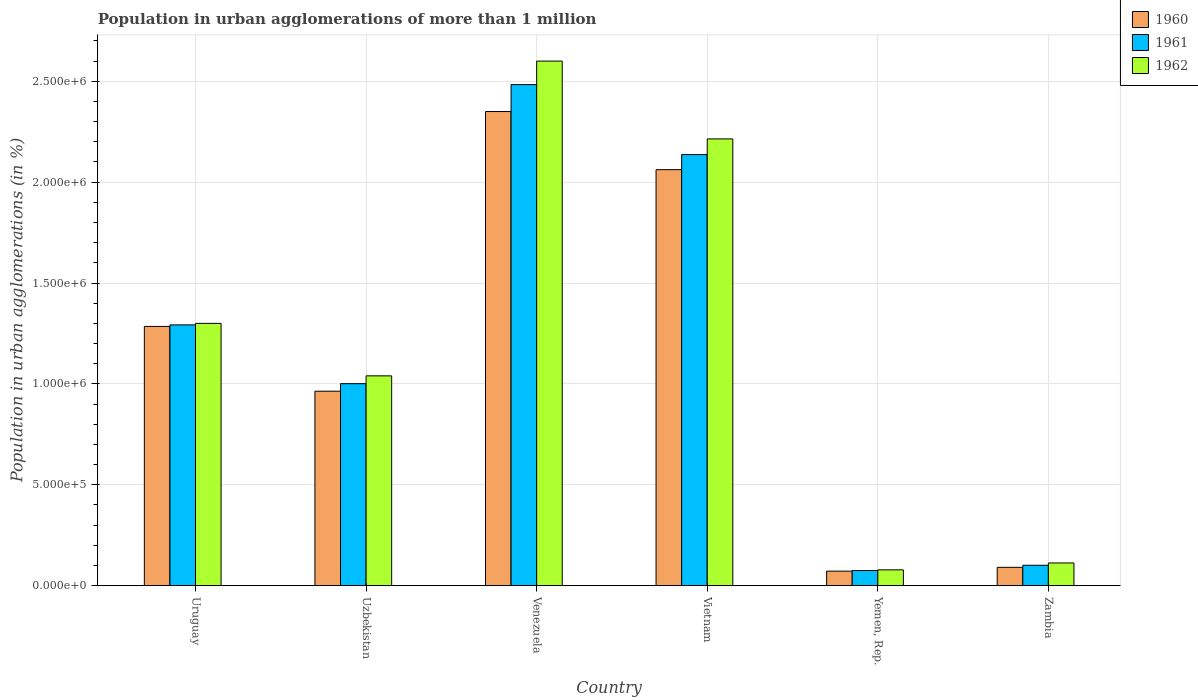How many different coloured bars are there?
Offer a very short reply. 3. How many groups of bars are there?
Your answer should be compact. 6. How many bars are there on the 6th tick from the right?
Ensure brevity in your answer.  3. What is the label of the 5th group of bars from the left?
Offer a very short reply. Yemen, Rep. In how many cases, is the number of bars for a given country not equal to the number of legend labels?
Give a very brief answer. 0. What is the population in urban agglomerations in 1961 in Vietnam?
Keep it short and to the point. 2.14e+06. Across all countries, what is the maximum population in urban agglomerations in 1960?
Offer a very short reply. 2.35e+06. Across all countries, what is the minimum population in urban agglomerations in 1962?
Offer a very short reply. 7.84e+04. In which country was the population in urban agglomerations in 1961 maximum?
Make the answer very short. Venezuela. In which country was the population in urban agglomerations in 1961 minimum?
Offer a very short reply. Yemen, Rep. What is the total population in urban agglomerations in 1961 in the graph?
Offer a very short reply. 7.09e+06. What is the difference between the population in urban agglomerations in 1960 in Uruguay and that in Venezuela?
Offer a terse response. -1.07e+06. What is the difference between the population in urban agglomerations in 1962 in Yemen, Rep. and the population in urban agglomerations in 1961 in Vietnam?
Offer a very short reply. -2.06e+06. What is the average population in urban agglomerations in 1962 per country?
Your answer should be compact. 1.22e+06. What is the difference between the population in urban agglomerations of/in 1961 and population in urban agglomerations of/in 1962 in Yemen, Rep.?
Give a very brief answer. -3293. What is the ratio of the population in urban agglomerations in 1961 in Uzbekistan to that in Zambia?
Your response must be concise. 9.89. Is the population in urban agglomerations in 1962 in Uruguay less than that in Vietnam?
Ensure brevity in your answer.  Yes. What is the difference between the highest and the second highest population in urban agglomerations in 1960?
Give a very brief answer. -2.88e+05. What is the difference between the highest and the lowest population in urban agglomerations in 1962?
Keep it short and to the point. 2.52e+06. How many bars are there?
Offer a terse response. 18. How many countries are there in the graph?
Keep it short and to the point. 6. Are the values on the major ticks of Y-axis written in scientific E-notation?
Ensure brevity in your answer.  Yes. Does the graph contain grids?
Make the answer very short. Yes. Where does the legend appear in the graph?
Give a very brief answer. Top right. What is the title of the graph?
Your answer should be very brief. Population in urban agglomerations of more than 1 million. What is the label or title of the X-axis?
Offer a very short reply. Country. What is the label or title of the Y-axis?
Provide a short and direct response. Population in urban agglomerations (in %). What is the Population in urban agglomerations (in %) in 1960 in Uruguay?
Offer a terse response. 1.28e+06. What is the Population in urban agglomerations (in %) in 1961 in Uruguay?
Your answer should be very brief. 1.29e+06. What is the Population in urban agglomerations (in %) in 1962 in Uruguay?
Make the answer very short. 1.30e+06. What is the Population in urban agglomerations (in %) in 1960 in Uzbekistan?
Provide a succinct answer. 9.64e+05. What is the Population in urban agglomerations (in %) of 1961 in Uzbekistan?
Offer a very short reply. 1.00e+06. What is the Population in urban agglomerations (in %) of 1962 in Uzbekistan?
Your response must be concise. 1.04e+06. What is the Population in urban agglomerations (in %) in 1960 in Venezuela?
Offer a terse response. 2.35e+06. What is the Population in urban agglomerations (in %) of 1961 in Venezuela?
Offer a terse response. 2.48e+06. What is the Population in urban agglomerations (in %) in 1962 in Venezuela?
Keep it short and to the point. 2.60e+06. What is the Population in urban agglomerations (in %) of 1960 in Vietnam?
Offer a very short reply. 2.06e+06. What is the Population in urban agglomerations (in %) in 1961 in Vietnam?
Provide a short and direct response. 2.14e+06. What is the Population in urban agglomerations (in %) of 1962 in Vietnam?
Give a very brief answer. 2.21e+06. What is the Population in urban agglomerations (in %) of 1960 in Yemen, Rep.?
Provide a succinct answer. 7.20e+04. What is the Population in urban agglomerations (in %) of 1961 in Yemen, Rep.?
Provide a succinct answer. 7.52e+04. What is the Population in urban agglomerations (in %) in 1962 in Yemen, Rep.?
Your answer should be very brief. 7.84e+04. What is the Population in urban agglomerations (in %) in 1960 in Zambia?
Keep it short and to the point. 9.09e+04. What is the Population in urban agglomerations (in %) in 1961 in Zambia?
Make the answer very short. 1.01e+05. What is the Population in urban agglomerations (in %) of 1962 in Zambia?
Your answer should be compact. 1.13e+05. Across all countries, what is the maximum Population in urban agglomerations (in %) of 1960?
Your response must be concise. 2.35e+06. Across all countries, what is the maximum Population in urban agglomerations (in %) in 1961?
Give a very brief answer. 2.48e+06. Across all countries, what is the maximum Population in urban agglomerations (in %) of 1962?
Your response must be concise. 2.60e+06. Across all countries, what is the minimum Population in urban agglomerations (in %) in 1960?
Ensure brevity in your answer.  7.20e+04. Across all countries, what is the minimum Population in urban agglomerations (in %) in 1961?
Your response must be concise. 7.52e+04. Across all countries, what is the minimum Population in urban agglomerations (in %) in 1962?
Provide a succinct answer. 7.84e+04. What is the total Population in urban agglomerations (in %) in 1960 in the graph?
Ensure brevity in your answer.  6.82e+06. What is the total Population in urban agglomerations (in %) of 1961 in the graph?
Provide a short and direct response. 7.09e+06. What is the total Population in urban agglomerations (in %) of 1962 in the graph?
Your answer should be very brief. 7.35e+06. What is the difference between the Population in urban agglomerations (in %) of 1960 in Uruguay and that in Uzbekistan?
Provide a succinct answer. 3.21e+05. What is the difference between the Population in urban agglomerations (in %) of 1961 in Uruguay and that in Uzbekistan?
Provide a succinct answer. 2.91e+05. What is the difference between the Population in urban agglomerations (in %) in 1962 in Uruguay and that in Uzbekistan?
Your answer should be compact. 2.60e+05. What is the difference between the Population in urban agglomerations (in %) of 1960 in Uruguay and that in Venezuela?
Your answer should be compact. -1.07e+06. What is the difference between the Population in urban agglomerations (in %) in 1961 in Uruguay and that in Venezuela?
Provide a short and direct response. -1.19e+06. What is the difference between the Population in urban agglomerations (in %) of 1962 in Uruguay and that in Venezuela?
Offer a very short reply. -1.30e+06. What is the difference between the Population in urban agglomerations (in %) in 1960 in Uruguay and that in Vietnam?
Your answer should be compact. -7.77e+05. What is the difference between the Population in urban agglomerations (in %) in 1961 in Uruguay and that in Vietnam?
Make the answer very short. -8.44e+05. What is the difference between the Population in urban agglomerations (in %) of 1962 in Uruguay and that in Vietnam?
Ensure brevity in your answer.  -9.14e+05. What is the difference between the Population in urban agglomerations (in %) in 1960 in Uruguay and that in Yemen, Rep.?
Offer a terse response. 1.21e+06. What is the difference between the Population in urban agglomerations (in %) of 1961 in Uruguay and that in Yemen, Rep.?
Provide a short and direct response. 1.22e+06. What is the difference between the Population in urban agglomerations (in %) in 1962 in Uruguay and that in Yemen, Rep.?
Give a very brief answer. 1.22e+06. What is the difference between the Population in urban agglomerations (in %) of 1960 in Uruguay and that in Zambia?
Keep it short and to the point. 1.19e+06. What is the difference between the Population in urban agglomerations (in %) of 1961 in Uruguay and that in Zambia?
Your response must be concise. 1.19e+06. What is the difference between the Population in urban agglomerations (in %) in 1962 in Uruguay and that in Zambia?
Make the answer very short. 1.19e+06. What is the difference between the Population in urban agglomerations (in %) of 1960 in Uzbekistan and that in Venezuela?
Provide a short and direct response. -1.39e+06. What is the difference between the Population in urban agglomerations (in %) in 1961 in Uzbekistan and that in Venezuela?
Provide a succinct answer. -1.48e+06. What is the difference between the Population in urban agglomerations (in %) of 1962 in Uzbekistan and that in Venezuela?
Provide a succinct answer. -1.56e+06. What is the difference between the Population in urban agglomerations (in %) in 1960 in Uzbekistan and that in Vietnam?
Your answer should be very brief. -1.10e+06. What is the difference between the Population in urban agglomerations (in %) of 1961 in Uzbekistan and that in Vietnam?
Provide a succinct answer. -1.14e+06. What is the difference between the Population in urban agglomerations (in %) in 1962 in Uzbekistan and that in Vietnam?
Make the answer very short. -1.17e+06. What is the difference between the Population in urban agglomerations (in %) of 1960 in Uzbekistan and that in Yemen, Rep.?
Offer a very short reply. 8.92e+05. What is the difference between the Population in urban agglomerations (in %) of 1961 in Uzbekistan and that in Yemen, Rep.?
Your response must be concise. 9.26e+05. What is the difference between the Population in urban agglomerations (in %) of 1962 in Uzbekistan and that in Yemen, Rep.?
Your answer should be very brief. 9.61e+05. What is the difference between the Population in urban agglomerations (in %) of 1960 in Uzbekistan and that in Zambia?
Make the answer very short. 8.73e+05. What is the difference between the Population in urban agglomerations (in %) of 1961 in Uzbekistan and that in Zambia?
Give a very brief answer. 9.00e+05. What is the difference between the Population in urban agglomerations (in %) of 1962 in Uzbekistan and that in Zambia?
Ensure brevity in your answer.  9.27e+05. What is the difference between the Population in urban agglomerations (in %) in 1960 in Venezuela and that in Vietnam?
Your answer should be very brief. 2.88e+05. What is the difference between the Population in urban agglomerations (in %) in 1961 in Venezuela and that in Vietnam?
Your response must be concise. 3.47e+05. What is the difference between the Population in urban agglomerations (in %) in 1962 in Venezuela and that in Vietnam?
Offer a very short reply. 3.86e+05. What is the difference between the Population in urban agglomerations (in %) in 1960 in Venezuela and that in Yemen, Rep.?
Your answer should be compact. 2.28e+06. What is the difference between the Population in urban agglomerations (in %) of 1961 in Venezuela and that in Yemen, Rep.?
Ensure brevity in your answer.  2.41e+06. What is the difference between the Population in urban agglomerations (in %) in 1962 in Venezuela and that in Yemen, Rep.?
Your response must be concise. 2.52e+06. What is the difference between the Population in urban agglomerations (in %) in 1960 in Venezuela and that in Zambia?
Provide a succinct answer. 2.26e+06. What is the difference between the Population in urban agglomerations (in %) in 1961 in Venezuela and that in Zambia?
Provide a short and direct response. 2.38e+06. What is the difference between the Population in urban agglomerations (in %) in 1962 in Venezuela and that in Zambia?
Offer a very short reply. 2.49e+06. What is the difference between the Population in urban agglomerations (in %) of 1960 in Vietnam and that in Yemen, Rep.?
Your response must be concise. 1.99e+06. What is the difference between the Population in urban agglomerations (in %) in 1961 in Vietnam and that in Yemen, Rep.?
Your answer should be compact. 2.06e+06. What is the difference between the Population in urban agglomerations (in %) in 1962 in Vietnam and that in Yemen, Rep.?
Give a very brief answer. 2.14e+06. What is the difference between the Population in urban agglomerations (in %) of 1960 in Vietnam and that in Zambia?
Make the answer very short. 1.97e+06. What is the difference between the Population in urban agglomerations (in %) of 1961 in Vietnam and that in Zambia?
Make the answer very short. 2.04e+06. What is the difference between the Population in urban agglomerations (in %) of 1962 in Vietnam and that in Zambia?
Keep it short and to the point. 2.10e+06. What is the difference between the Population in urban agglomerations (in %) of 1960 in Yemen, Rep. and that in Zambia?
Make the answer very short. -1.89e+04. What is the difference between the Population in urban agglomerations (in %) of 1961 in Yemen, Rep. and that in Zambia?
Ensure brevity in your answer.  -2.61e+04. What is the difference between the Population in urban agglomerations (in %) of 1962 in Yemen, Rep. and that in Zambia?
Keep it short and to the point. -3.42e+04. What is the difference between the Population in urban agglomerations (in %) in 1960 in Uruguay and the Population in urban agglomerations (in %) in 1961 in Uzbekistan?
Provide a succinct answer. 2.84e+05. What is the difference between the Population in urban agglomerations (in %) of 1960 in Uruguay and the Population in urban agglomerations (in %) of 1962 in Uzbekistan?
Provide a short and direct response. 2.45e+05. What is the difference between the Population in urban agglomerations (in %) in 1961 in Uruguay and the Population in urban agglomerations (in %) in 1962 in Uzbekistan?
Give a very brief answer. 2.53e+05. What is the difference between the Population in urban agglomerations (in %) of 1960 in Uruguay and the Population in urban agglomerations (in %) of 1961 in Venezuela?
Your answer should be compact. -1.20e+06. What is the difference between the Population in urban agglomerations (in %) of 1960 in Uruguay and the Population in urban agglomerations (in %) of 1962 in Venezuela?
Provide a succinct answer. -1.31e+06. What is the difference between the Population in urban agglomerations (in %) of 1961 in Uruguay and the Population in urban agglomerations (in %) of 1962 in Venezuela?
Offer a terse response. -1.31e+06. What is the difference between the Population in urban agglomerations (in %) in 1960 in Uruguay and the Population in urban agglomerations (in %) in 1961 in Vietnam?
Keep it short and to the point. -8.52e+05. What is the difference between the Population in urban agglomerations (in %) in 1960 in Uruguay and the Population in urban agglomerations (in %) in 1962 in Vietnam?
Give a very brief answer. -9.29e+05. What is the difference between the Population in urban agglomerations (in %) of 1961 in Uruguay and the Population in urban agglomerations (in %) of 1962 in Vietnam?
Your answer should be compact. -9.22e+05. What is the difference between the Population in urban agglomerations (in %) in 1960 in Uruguay and the Population in urban agglomerations (in %) in 1961 in Yemen, Rep.?
Keep it short and to the point. 1.21e+06. What is the difference between the Population in urban agglomerations (in %) of 1960 in Uruguay and the Population in urban agglomerations (in %) of 1962 in Yemen, Rep.?
Make the answer very short. 1.21e+06. What is the difference between the Population in urban agglomerations (in %) in 1961 in Uruguay and the Population in urban agglomerations (in %) in 1962 in Yemen, Rep.?
Your answer should be very brief. 1.21e+06. What is the difference between the Population in urban agglomerations (in %) of 1960 in Uruguay and the Population in urban agglomerations (in %) of 1961 in Zambia?
Ensure brevity in your answer.  1.18e+06. What is the difference between the Population in urban agglomerations (in %) of 1960 in Uruguay and the Population in urban agglomerations (in %) of 1962 in Zambia?
Keep it short and to the point. 1.17e+06. What is the difference between the Population in urban agglomerations (in %) in 1961 in Uruguay and the Population in urban agglomerations (in %) in 1962 in Zambia?
Provide a succinct answer. 1.18e+06. What is the difference between the Population in urban agglomerations (in %) in 1960 in Uzbekistan and the Population in urban agglomerations (in %) in 1961 in Venezuela?
Ensure brevity in your answer.  -1.52e+06. What is the difference between the Population in urban agglomerations (in %) of 1960 in Uzbekistan and the Population in urban agglomerations (in %) of 1962 in Venezuela?
Your answer should be compact. -1.64e+06. What is the difference between the Population in urban agglomerations (in %) of 1961 in Uzbekistan and the Population in urban agglomerations (in %) of 1962 in Venezuela?
Give a very brief answer. -1.60e+06. What is the difference between the Population in urban agglomerations (in %) of 1960 in Uzbekistan and the Population in urban agglomerations (in %) of 1961 in Vietnam?
Provide a short and direct response. -1.17e+06. What is the difference between the Population in urban agglomerations (in %) of 1960 in Uzbekistan and the Population in urban agglomerations (in %) of 1962 in Vietnam?
Your answer should be very brief. -1.25e+06. What is the difference between the Population in urban agglomerations (in %) of 1961 in Uzbekistan and the Population in urban agglomerations (in %) of 1962 in Vietnam?
Ensure brevity in your answer.  -1.21e+06. What is the difference between the Population in urban agglomerations (in %) of 1960 in Uzbekistan and the Population in urban agglomerations (in %) of 1961 in Yemen, Rep.?
Provide a short and direct response. 8.89e+05. What is the difference between the Population in urban agglomerations (in %) of 1960 in Uzbekistan and the Population in urban agglomerations (in %) of 1962 in Yemen, Rep.?
Provide a short and direct response. 8.85e+05. What is the difference between the Population in urban agglomerations (in %) of 1961 in Uzbekistan and the Population in urban agglomerations (in %) of 1962 in Yemen, Rep.?
Offer a terse response. 9.23e+05. What is the difference between the Population in urban agglomerations (in %) in 1960 in Uzbekistan and the Population in urban agglomerations (in %) in 1961 in Zambia?
Your answer should be very brief. 8.63e+05. What is the difference between the Population in urban agglomerations (in %) of 1960 in Uzbekistan and the Population in urban agglomerations (in %) of 1962 in Zambia?
Give a very brief answer. 8.51e+05. What is the difference between the Population in urban agglomerations (in %) in 1961 in Uzbekistan and the Population in urban agglomerations (in %) in 1962 in Zambia?
Ensure brevity in your answer.  8.89e+05. What is the difference between the Population in urban agglomerations (in %) in 1960 in Venezuela and the Population in urban agglomerations (in %) in 1961 in Vietnam?
Offer a terse response. 2.13e+05. What is the difference between the Population in urban agglomerations (in %) of 1960 in Venezuela and the Population in urban agglomerations (in %) of 1962 in Vietnam?
Make the answer very short. 1.36e+05. What is the difference between the Population in urban agglomerations (in %) of 1961 in Venezuela and the Population in urban agglomerations (in %) of 1962 in Vietnam?
Offer a very short reply. 2.69e+05. What is the difference between the Population in urban agglomerations (in %) of 1960 in Venezuela and the Population in urban agglomerations (in %) of 1961 in Yemen, Rep.?
Make the answer very short. 2.27e+06. What is the difference between the Population in urban agglomerations (in %) of 1960 in Venezuela and the Population in urban agglomerations (in %) of 1962 in Yemen, Rep.?
Provide a short and direct response. 2.27e+06. What is the difference between the Population in urban agglomerations (in %) of 1961 in Venezuela and the Population in urban agglomerations (in %) of 1962 in Yemen, Rep.?
Keep it short and to the point. 2.40e+06. What is the difference between the Population in urban agglomerations (in %) in 1960 in Venezuela and the Population in urban agglomerations (in %) in 1961 in Zambia?
Keep it short and to the point. 2.25e+06. What is the difference between the Population in urban agglomerations (in %) in 1960 in Venezuela and the Population in urban agglomerations (in %) in 1962 in Zambia?
Your answer should be very brief. 2.24e+06. What is the difference between the Population in urban agglomerations (in %) of 1961 in Venezuela and the Population in urban agglomerations (in %) of 1962 in Zambia?
Your answer should be compact. 2.37e+06. What is the difference between the Population in urban agglomerations (in %) of 1960 in Vietnam and the Population in urban agglomerations (in %) of 1961 in Yemen, Rep.?
Make the answer very short. 1.99e+06. What is the difference between the Population in urban agglomerations (in %) of 1960 in Vietnam and the Population in urban agglomerations (in %) of 1962 in Yemen, Rep.?
Ensure brevity in your answer.  1.98e+06. What is the difference between the Population in urban agglomerations (in %) of 1961 in Vietnam and the Population in urban agglomerations (in %) of 1962 in Yemen, Rep.?
Give a very brief answer. 2.06e+06. What is the difference between the Population in urban agglomerations (in %) of 1960 in Vietnam and the Population in urban agglomerations (in %) of 1961 in Zambia?
Provide a short and direct response. 1.96e+06. What is the difference between the Population in urban agglomerations (in %) in 1960 in Vietnam and the Population in urban agglomerations (in %) in 1962 in Zambia?
Your response must be concise. 1.95e+06. What is the difference between the Population in urban agglomerations (in %) in 1961 in Vietnam and the Population in urban agglomerations (in %) in 1962 in Zambia?
Offer a terse response. 2.02e+06. What is the difference between the Population in urban agglomerations (in %) of 1960 in Yemen, Rep. and the Population in urban agglomerations (in %) of 1961 in Zambia?
Your answer should be very brief. -2.92e+04. What is the difference between the Population in urban agglomerations (in %) in 1960 in Yemen, Rep. and the Population in urban agglomerations (in %) in 1962 in Zambia?
Keep it short and to the point. -4.06e+04. What is the difference between the Population in urban agglomerations (in %) in 1961 in Yemen, Rep. and the Population in urban agglomerations (in %) in 1962 in Zambia?
Make the answer very short. -3.75e+04. What is the average Population in urban agglomerations (in %) in 1960 per country?
Ensure brevity in your answer.  1.14e+06. What is the average Population in urban agglomerations (in %) of 1961 per country?
Offer a terse response. 1.18e+06. What is the average Population in urban agglomerations (in %) in 1962 per country?
Keep it short and to the point. 1.22e+06. What is the difference between the Population in urban agglomerations (in %) in 1960 and Population in urban agglomerations (in %) in 1961 in Uruguay?
Ensure brevity in your answer.  -7522. What is the difference between the Population in urban agglomerations (in %) in 1960 and Population in urban agglomerations (in %) in 1962 in Uruguay?
Your answer should be compact. -1.51e+04. What is the difference between the Population in urban agglomerations (in %) in 1961 and Population in urban agglomerations (in %) in 1962 in Uruguay?
Your answer should be very brief. -7578. What is the difference between the Population in urban agglomerations (in %) in 1960 and Population in urban agglomerations (in %) in 1961 in Uzbekistan?
Keep it short and to the point. -3.73e+04. What is the difference between the Population in urban agglomerations (in %) in 1960 and Population in urban agglomerations (in %) in 1962 in Uzbekistan?
Keep it short and to the point. -7.60e+04. What is the difference between the Population in urban agglomerations (in %) of 1961 and Population in urban agglomerations (in %) of 1962 in Uzbekistan?
Ensure brevity in your answer.  -3.88e+04. What is the difference between the Population in urban agglomerations (in %) in 1960 and Population in urban agglomerations (in %) in 1961 in Venezuela?
Your answer should be very brief. -1.33e+05. What is the difference between the Population in urban agglomerations (in %) of 1960 and Population in urban agglomerations (in %) of 1962 in Venezuela?
Give a very brief answer. -2.50e+05. What is the difference between the Population in urban agglomerations (in %) in 1961 and Population in urban agglomerations (in %) in 1962 in Venezuela?
Your answer should be very brief. -1.16e+05. What is the difference between the Population in urban agglomerations (in %) of 1960 and Population in urban agglomerations (in %) of 1961 in Vietnam?
Provide a short and direct response. -7.48e+04. What is the difference between the Population in urban agglomerations (in %) of 1960 and Population in urban agglomerations (in %) of 1962 in Vietnam?
Provide a short and direct response. -1.52e+05. What is the difference between the Population in urban agglomerations (in %) in 1961 and Population in urban agglomerations (in %) in 1962 in Vietnam?
Give a very brief answer. -7.76e+04. What is the difference between the Population in urban agglomerations (in %) of 1960 and Population in urban agglomerations (in %) of 1961 in Yemen, Rep.?
Offer a terse response. -3151. What is the difference between the Population in urban agglomerations (in %) in 1960 and Population in urban agglomerations (in %) in 1962 in Yemen, Rep.?
Offer a very short reply. -6444. What is the difference between the Population in urban agglomerations (in %) of 1961 and Population in urban agglomerations (in %) of 1962 in Yemen, Rep.?
Offer a very short reply. -3293. What is the difference between the Population in urban agglomerations (in %) of 1960 and Population in urban agglomerations (in %) of 1961 in Zambia?
Keep it short and to the point. -1.03e+04. What is the difference between the Population in urban agglomerations (in %) of 1960 and Population in urban agglomerations (in %) of 1962 in Zambia?
Make the answer very short. -2.17e+04. What is the difference between the Population in urban agglomerations (in %) in 1961 and Population in urban agglomerations (in %) in 1962 in Zambia?
Your answer should be compact. -1.14e+04. What is the ratio of the Population in urban agglomerations (in %) in 1960 in Uruguay to that in Uzbekistan?
Ensure brevity in your answer.  1.33. What is the ratio of the Population in urban agglomerations (in %) of 1961 in Uruguay to that in Uzbekistan?
Your answer should be very brief. 1.29. What is the ratio of the Population in urban agglomerations (in %) of 1962 in Uruguay to that in Uzbekistan?
Your answer should be very brief. 1.25. What is the ratio of the Population in urban agglomerations (in %) of 1960 in Uruguay to that in Venezuela?
Your response must be concise. 0.55. What is the ratio of the Population in urban agglomerations (in %) in 1961 in Uruguay to that in Venezuela?
Your response must be concise. 0.52. What is the ratio of the Population in urban agglomerations (in %) in 1962 in Uruguay to that in Venezuela?
Your answer should be very brief. 0.5. What is the ratio of the Population in urban agglomerations (in %) of 1960 in Uruguay to that in Vietnam?
Offer a terse response. 0.62. What is the ratio of the Population in urban agglomerations (in %) in 1961 in Uruguay to that in Vietnam?
Provide a succinct answer. 0.6. What is the ratio of the Population in urban agglomerations (in %) of 1962 in Uruguay to that in Vietnam?
Provide a succinct answer. 0.59. What is the ratio of the Population in urban agglomerations (in %) of 1960 in Uruguay to that in Yemen, Rep.?
Your response must be concise. 17.85. What is the ratio of the Population in urban agglomerations (in %) in 1961 in Uruguay to that in Yemen, Rep.?
Provide a succinct answer. 17.2. What is the ratio of the Population in urban agglomerations (in %) of 1962 in Uruguay to that in Yemen, Rep.?
Your answer should be compact. 16.57. What is the ratio of the Population in urban agglomerations (in %) in 1960 in Uruguay to that in Zambia?
Give a very brief answer. 14.13. What is the ratio of the Population in urban agglomerations (in %) in 1961 in Uruguay to that in Zambia?
Offer a terse response. 12.77. What is the ratio of the Population in urban agglomerations (in %) in 1962 in Uruguay to that in Zambia?
Your answer should be compact. 11.54. What is the ratio of the Population in urban agglomerations (in %) in 1960 in Uzbekistan to that in Venezuela?
Provide a short and direct response. 0.41. What is the ratio of the Population in urban agglomerations (in %) of 1961 in Uzbekistan to that in Venezuela?
Give a very brief answer. 0.4. What is the ratio of the Population in urban agglomerations (in %) in 1960 in Uzbekistan to that in Vietnam?
Provide a succinct answer. 0.47. What is the ratio of the Population in urban agglomerations (in %) in 1961 in Uzbekistan to that in Vietnam?
Give a very brief answer. 0.47. What is the ratio of the Population in urban agglomerations (in %) in 1962 in Uzbekistan to that in Vietnam?
Offer a very short reply. 0.47. What is the ratio of the Population in urban agglomerations (in %) in 1960 in Uzbekistan to that in Yemen, Rep.?
Make the answer very short. 13.39. What is the ratio of the Population in urban agglomerations (in %) of 1961 in Uzbekistan to that in Yemen, Rep.?
Provide a succinct answer. 13.32. What is the ratio of the Population in urban agglomerations (in %) in 1962 in Uzbekistan to that in Yemen, Rep.?
Provide a short and direct response. 13.26. What is the ratio of the Population in urban agglomerations (in %) in 1960 in Uzbekistan to that in Zambia?
Ensure brevity in your answer.  10.6. What is the ratio of the Population in urban agglomerations (in %) in 1961 in Uzbekistan to that in Zambia?
Provide a succinct answer. 9.89. What is the ratio of the Population in urban agglomerations (in %) of 1962 in Uzbekistan to that in Zambia?
Offer a terse response. 9.23. What is the ratio of the Population in urban agglomerations (in %) of 1960 in Venezuela to that in Vietnam?
Offer a terse response. 1.14. What is the ratio of the Population in urban agglomerations (in %) in 1961 in Venezuela to that in Vietnam?
Your answer should be compact. 1.16. What is the ratio of the Population in urban agglomerations (in %) in 1962 in Venezuela to that in Vietnam?
Your answer should be compact. 1.17. What is the ratio of the Population in urban agglomerations (in %) in 1960 in Venezuela to that in Yemen, Rep.?
Your answer should be compact. 32.64. What is the ratio of the Population in urban agglomerations (in %) in 1961 in Venezuela to that in Yemen, Rep.?
Provide a short and direct response. 33.05. What is the ratio of the Population in urban agglomerations (in %) in 1962 in Venezuela to that in Yemen, Rep.?
Provide a succinct answer. 33.14. What is the ratio of the Population in urban agglomerations (in %) of 1960 in Venezuela to that in Zambia?
Make the answer very short. 25.84. What is the ratio of the Population in urban agglomerations (in %) of 1961 in Venezuela to that in Zambia?
Ensure brevity in your answer.  24.54. What is the ratio of the Population in urban agglomerations (in %) in 1962 in Venezuela to that in Zambia?
Your answer should be very brief. 23.08. What is the ratio of the Population in urban agglomerations (in %) of 1960 in Vietnam to that in Yemen, Rep.?
Your answer should be compact. 28.64. What is the ratio of the Population in urban agglomerations (in %) in 1961 in Vietnam to that in Yemen, Rep.?
Your answer should be very brief. 28.43. What is the ratio of the Population in urban agglomerations (in %) in 1962 in Vietnam to that in Yemen, Rep.?
Keep it short and to the point. 28.23. What is the ratio of the Population in urban agglomerations (in %) in 1960 in Vietnam to that in Zambia?
Make the answer very short. 22.67. What is the ratio of the Population in urban agglomerations (in %) in 1961 in Vietnam to that in Zambia?
Keep it short and to the point. 21.11. What is the ratio of the Population in urban agglomerations (in %) of 1962 in Vietnam to that in Zambia?
Give a very brief answer. 19.66. What is the ratio of the Population in urban agglomerations (in %) in 1960 in Yemen, Rep. to that in Zambia?
Give a very brief answer. 0.79. What is the ratio of the Population in urban agglomerations (in %) in 1961 in Yemen, Rep. to that in Zambia?
Keep it short and to the point. 0.74. What is the ratio of the Population in urban agglomerations (in %) of 1962 in Yemen, Rep. to that in Zambia?
Your response must be concise. 0.7. What is the difference between the highest and the second highest Population in urban agglomerations (in %) of 1960?
Offer a terse response. 2.88e+05. What is the difference between the highest and the second highest Population in urban agglomerations (in %) in 1961?
Offer a terse response. 3.47e+05. What is the difference between the highest and the second highest Population in urban agglomerations (in %) in 1962?
Give a very brief answer. 3.86e+05. What is the difference between the highest and the lowest Population in urban agglomerations (in %) of 1960?
Make the answer very short. 2.28e+06. What is the difference between the highest and the lowest Population in urban agglomerations (in %) of 1961?
Offer a very short reply. 2.41e+06. What is the difference between the highest and the lowest Population in urban agglomerations (in %) in 1962?
Give a very brief answer. 2.52e+06. 